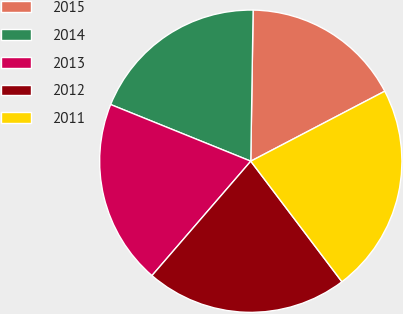<chart> <loc_0><loc_0><loc_500><loc_500><pie_chart><fcel>2015<fcel>2014<fcel>2013<fcel>2012<fcel>2011<nl><fcel>17.09%<fcel>19.13%<fcel>19.78%<fcel>21.64%<fcel>22.36%<nl></chart> 